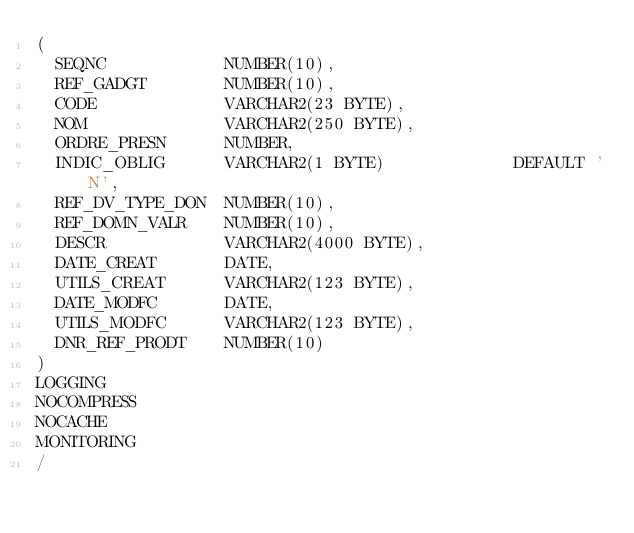Convert code to text. <code><loc_0><loc_0><loc_500><loc_500><_SQL_>(
  SEQNC            NUMBER(10),
  REF_GADGT        NUMBER(10),
  CODE             VARCHAR2(23 BYTE),
  NOM              VARCHAR2(250 BYTE),
  ORDRE_PRESN      NUMBER,
  INDIC_OBLIG      VARCHAR2(1 BYTE)             DEFAULT 'N',
  REF_DV_TYPE_DON  NUMBER(10),
  REF_DOMN_VALR    NUMBER(10),
  DESCR            VARCHAR2(4000 BYTE),
  DATE_CREAT       DATE,
  UTILS_CREAT      VARCHAR2(123 BYTE),
  DATE_MODFC       DATE,
  UTILS_MODFC      VARCHAR2(123 BYTE),
  DNR_REF_PRODT    NUMBER(10)
)
LOGGING 
NOCOMPRESS 
NOCACHE
MONITORING
/
</code> 